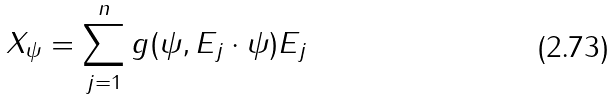<formula> <loc_0><loc_0><loc_500><loc_500>X _ { \psi } = \sum _ { j = 1 } ^ { n } g ( \psi , E _ { j } \cdot \psi ) E _ { j }</formula> 